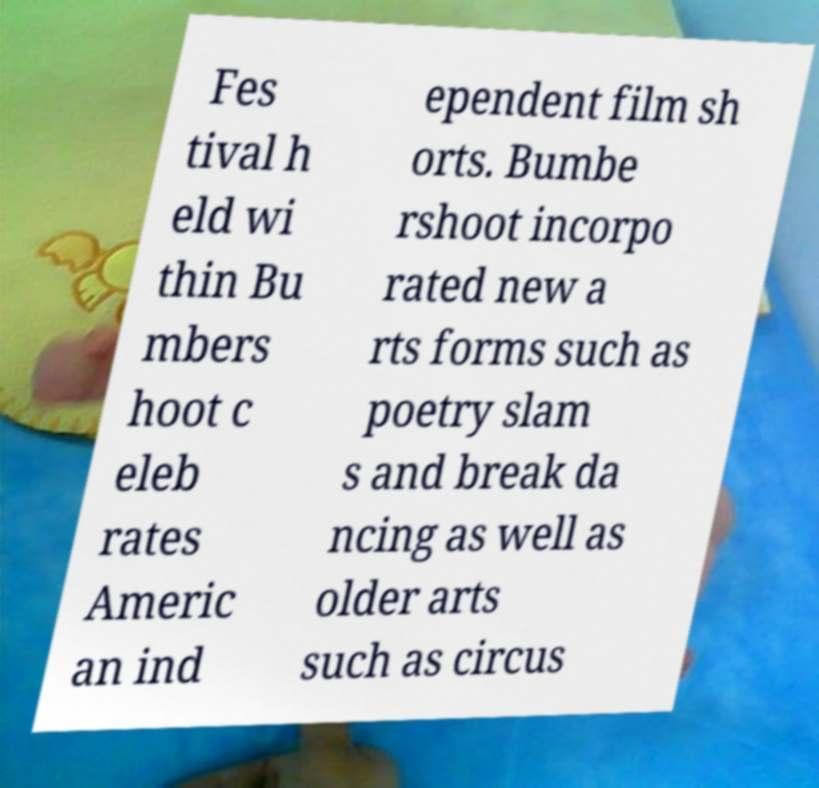I need the written content from this picture converted into text. Can you do that? Fes tival h eld wi thin Bu mbers hoot c eleb rates Americ an ind ependent film sh orts. Bumbe rshoot incorpo rated new a rts forms such as poetry slam s and break da ncing as well as older arts such as circus 